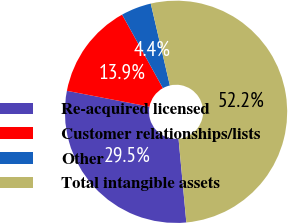<chart> <loc_0><loc_0><loc_500><loc_500><pie_chart><fcel>Re-acquired licensed<fcel>Customer relationships/lists<fcel>Other<fcel>Total intangible assets<nl><fcel>29.5%<fcel>13.91%<fcel>4.41%<fcel>52.17%<nl></chart> 